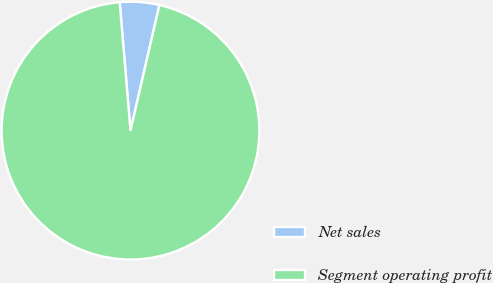<chart> <loc_0><loc_0><loc_500><loc_500><pie_chart><fcel>Net sales<fcel>Segment operating profit<nl><fcel>4.94%<fcel>95.06%<nl></chart> 